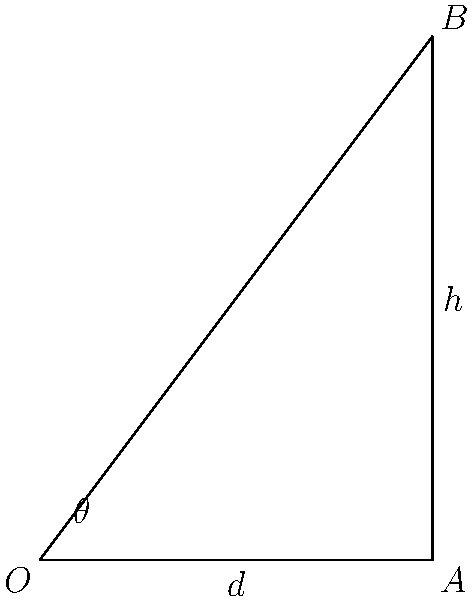As a best-selling author, you're designing the perfect reading nook for your home office. You want to position a reading lamp at point B, 4 feet above your desk (point A), which extends 3 feet from the wall (point O). What is the optimal angle $\theta$ (in degrees) at which the lamp should be tilted to provide the best illumination for your writing surface? To find the optimal angle $\theta$, we need to use trigonometry. The best illumination is typically achieved when the lamp is angled perpendicular to the line connecting points A and B.

Let's approach this step-by-step:

1) First, we need to find the angle between OA and AB. We can do this using the arctangent function.

2) The opposite side (height) is 4 feet, and the adjacent side (desk length) is 3 feet.

3) The angle BAO is calculated as:
   $$\theta_{BAO} = \arctan(\frac{4}{3}) \approx 53.13^\circ$$

4) The optimal angle for the lamp would be perpendicular to AB, which means it should be tilted 90° from this angle.

5) Therefore, the optimal angle $\theta$ is:
   $$\theta = 90^\circ - 53.13^\circ \approx 36.87^\circ$$

6) Rounding to the nearest degree, we get 37°.

This angle will ensure that the light from your lamp is directed perpendicularly to your writing surface, providing optimal illumination for your literary work.
Answer: 37° 